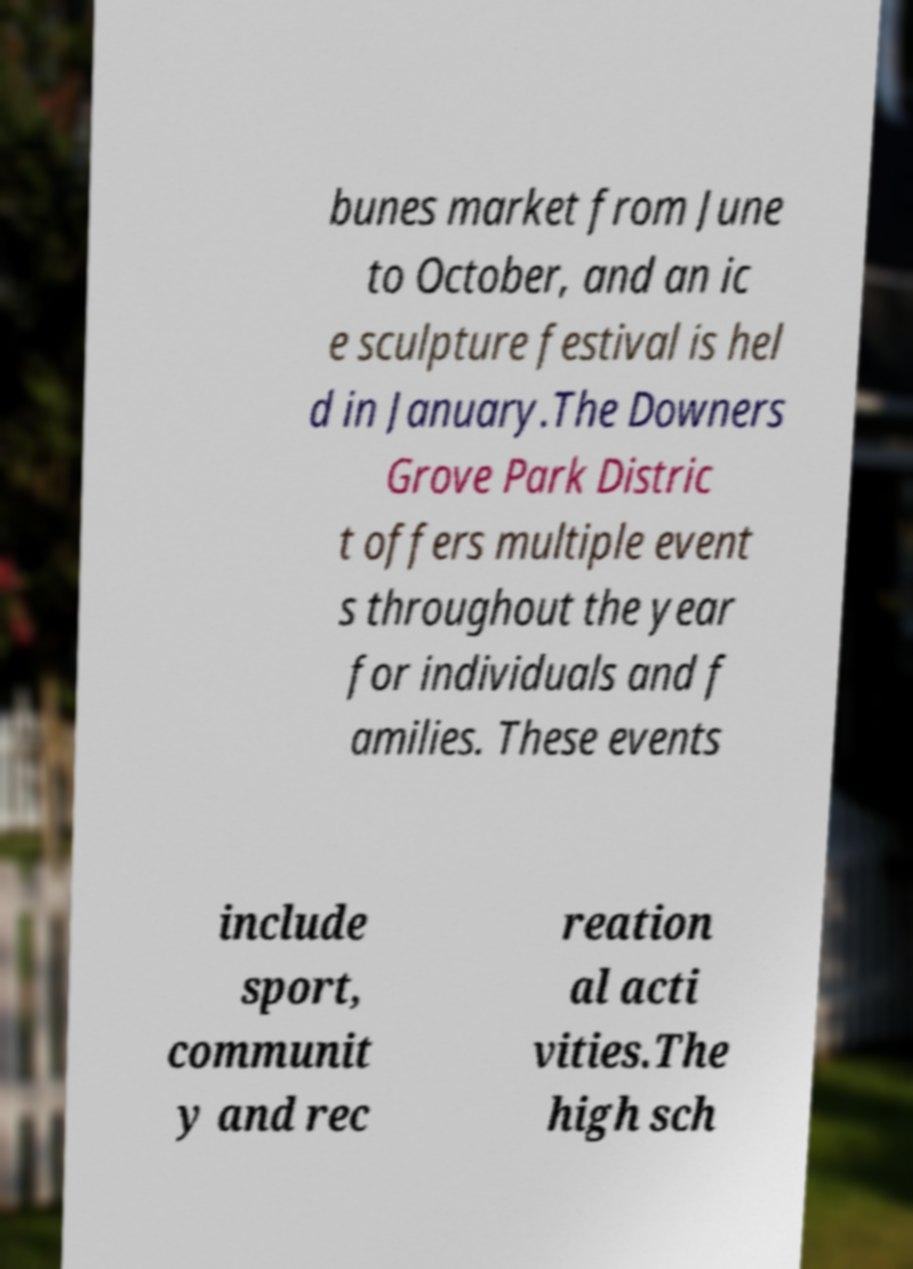There's text embedded in this image that I need extracted. Can you transcribe it verbatim? bunes market from June to October, and an ic e sculpture festival is hel d in January.The Downers Grove Park Distric t offers multiple event s throughout the year for individuals and f amilies. These events include sport, communit y and rec reation al acti vities.The high sch 